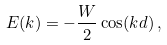Convert formula to latex. <formula><loc_0><loc_0><loc_500><loc_500>E ( k ) = - \frac { W } 2 \cos ( k d ) \, ,</formula> 